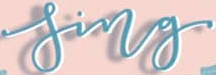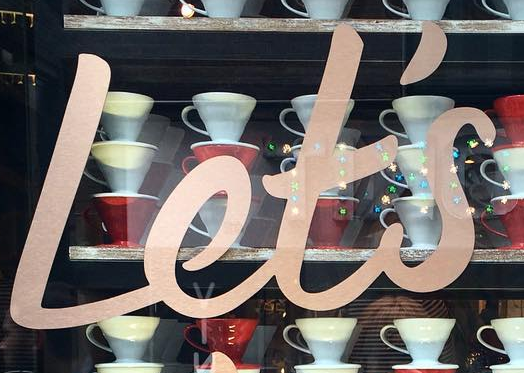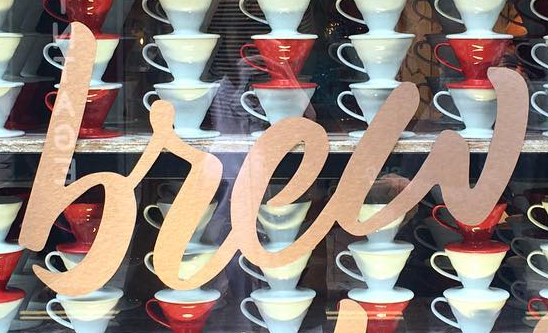What text appears in these images from left to right, separated by a semicolon? sing; Let's; brew 